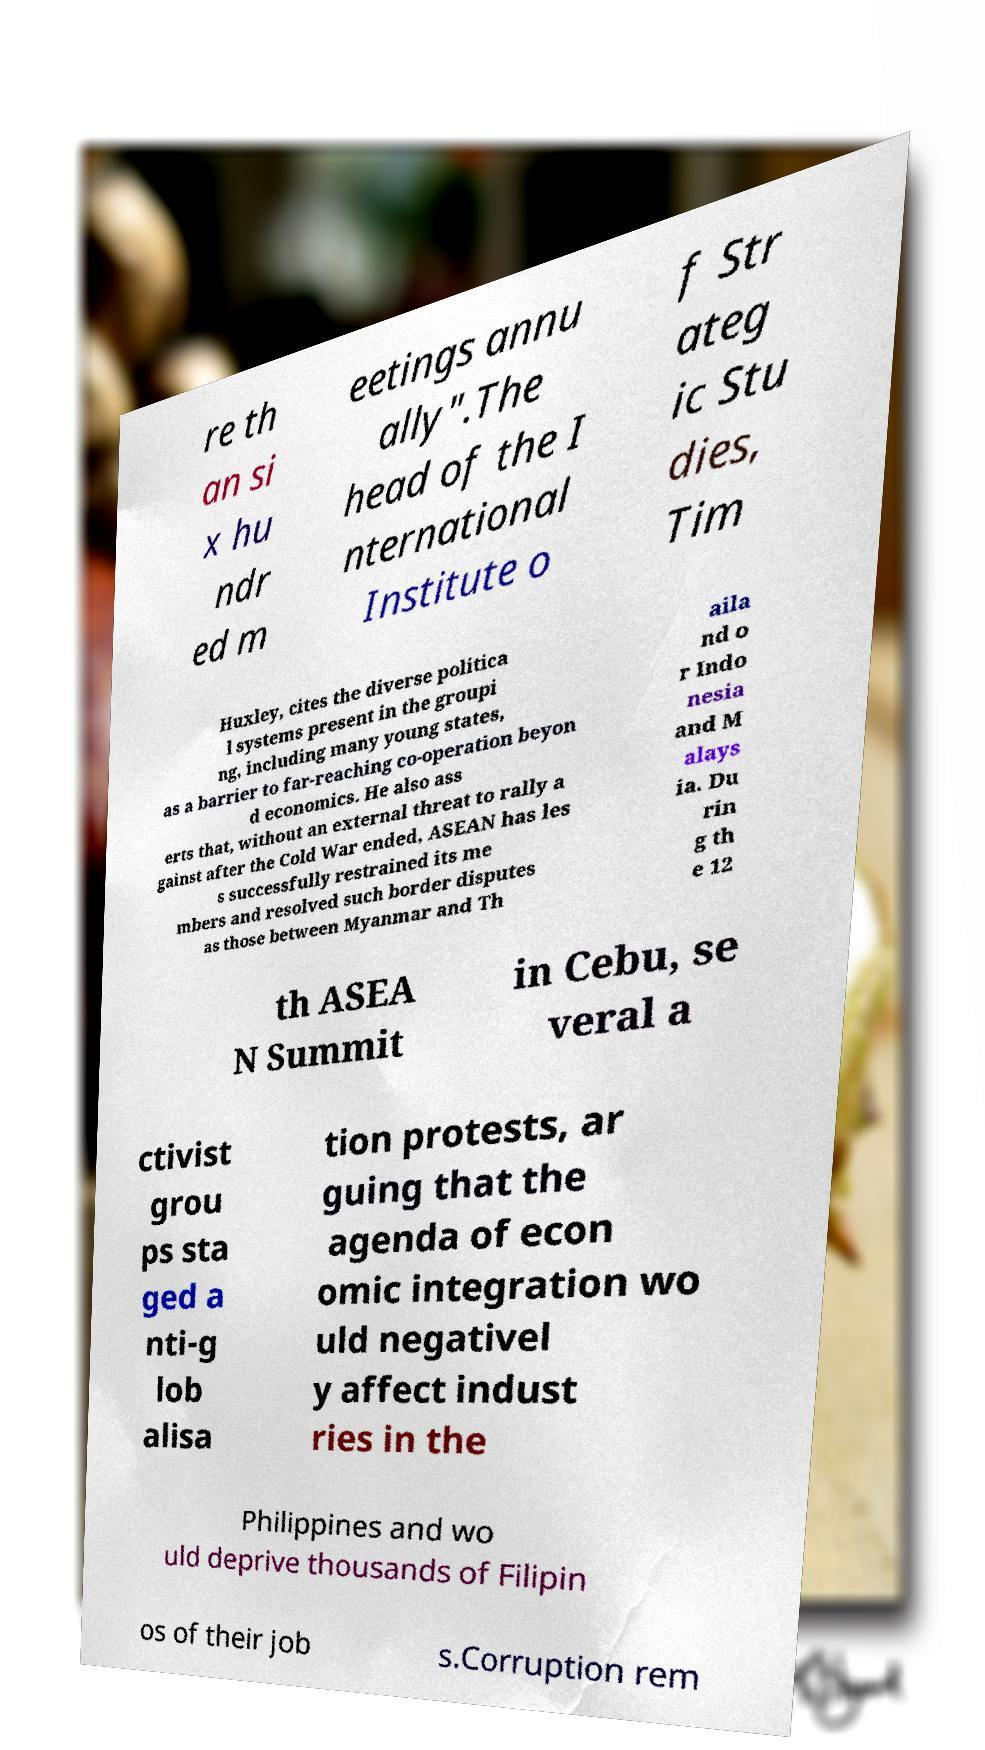Could you assist in decoding the text presented in this image and type it out clearly? re th an si x hu ndr ed m eetings annu ally".The head of the I nternational Institute o f Str ateg ic Stu dies, Tim Huxley, cites the diverse politica l systems present in the groupi ng, including many young states, as a barrier to far-reaching co-operation beyon d economics. He also ass erts that, without an external threat to rally a gainst after the Cold War ended, ASEAN has les s successfully restrained its me mbers and resolved such border disputes as those between Myanmar and Th aila nd o r Indo nesia and M alays ia. Du rin g th e 12 th ASEA N Summit in Cebu, se veral a ctivist grou ps sta ged a nti-g lob alisa tion protests, ar guing that the agenda of econ omic integration wo uld negativel y affect indust ries in the Philippines and wo uld deprive thousands of Filipin os of their job s.Corruption rem 